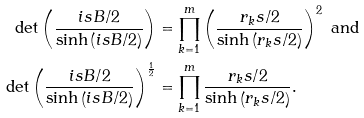Convert formula to latex. <formula><loc_0><loc_0><loc_500><loc_500>\det \left ( \frac { i s B / 2 } { \sinh \left ( i s B / 2 \right ) } \right ) & = \prod _ { k = 1 } ^ { m } \left ( \frac { r _ { k } s / 2 } { \sinh \left ( r _ { k } s / 2 \right ) } \right ) ^ { 2 } \text { and } \\ \det \left ( \frac { i s B / 2 } { \sinh \left ( i s B / 2 \right ) } \right ) ^ { \frac { 1 } { 2 } } & = \prod _ { k = 1 } ^ { m } \frac { r _ { k } s / 2 } { \sinh \left ( r _ { k } s / 2 \right ) } .</formula> 